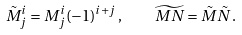Convert formula to latex. <formula><loc_0><loc_0><loc_500><loc_500>\tilde { M } ^ { i } _ { j } = M ^ { i } _ { j } ( - 1 ) ^ { i + j } \, , \quad \widetilde { M N } = \tilde { M } \tilde { N } \, .</formula> 